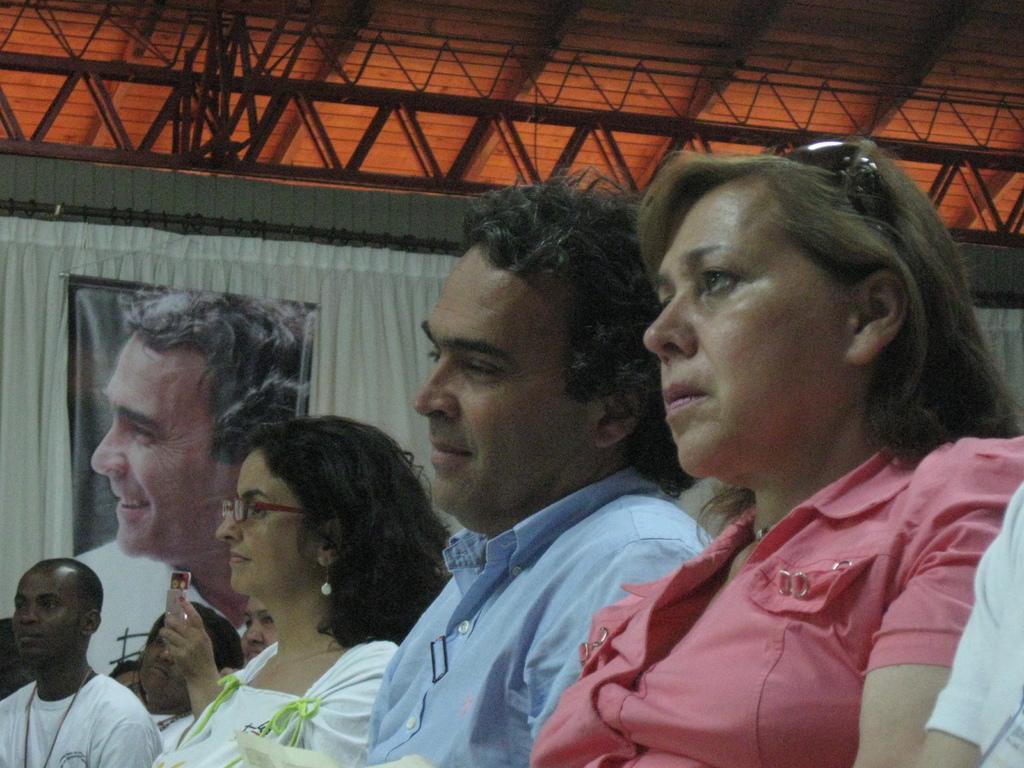Please provide a concise description of this image. In this image there are people sitting on chairs, in the background there is a curtain, on that curtain there is a poster of a man, on the top there are roads and iron frame. 